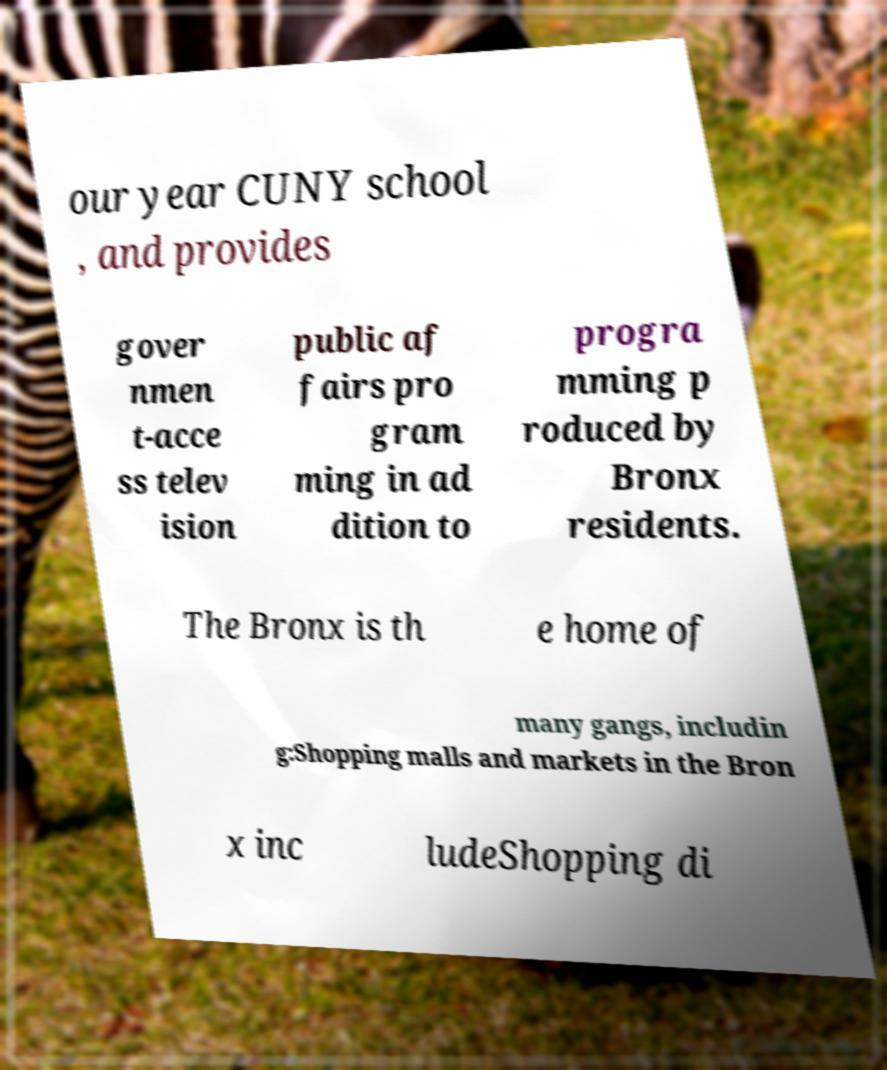I need the written content from this picture converted into text. Can you do that? our year CUNY school , and provides gover nmen t-acce ss telev ision public af fairs pro gram ming in ad dition to progra mming p roduced by Bronx residents. The Bronx is th e home of many gangs, includin g:Shopping malls and markets in the Bron x inc ludeShopping di 